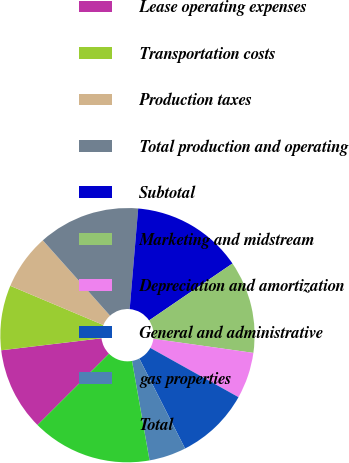<chart> <loc_0><loc_0><loc_500><loc_500><pie_chart><fcel>Lease operating expenses<fcel>Transportation costs<fcel>Production taxes<fcel>Total production and operating<fcel>Subtotal<fcel>Marketing and midstream<fcel>Depreciation and amortization<fcel>General and administrative<fcel>gas properties<fcel>Total<nl><fcel>10.59%<fcel>8.24%<fcel>7.06%<fcel>12.94%<fcel>14.12%<fcel>11.76%<fcel>5.88%<fcel>9.41%<fcel>4.71%<fcel>15.29%<nl></chart> 